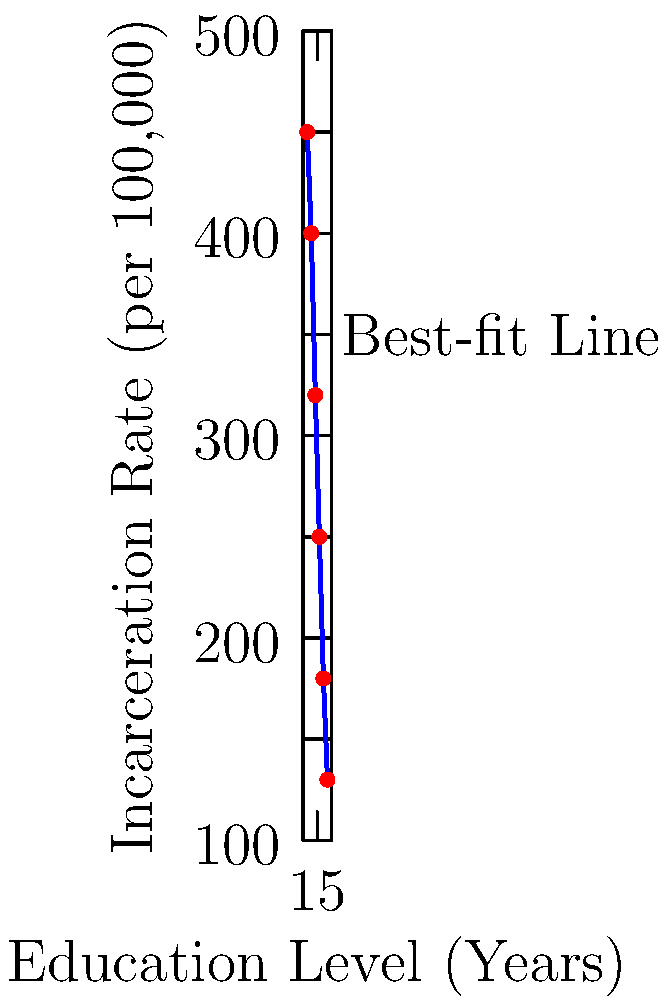Based on the scatter plot and best-fit line shown, which of the following statements best describes the relationship between education levels and incarceration rates? 

A) There is a strong positive correlation
B) There is a weak negative correlation
C) There is a strong negative correlation
D) There is no clear correlation To interpret the correlation between education levels and incarceration rates using the scatter plot and best-fit line, we need to analyze the following:

1. Direction of the relationship: The best-fit line slopes downward from left to right, indicating a negative relationship.

2. Strength of the relationship: The data points are closely clustered around the best-fit line, suggesting a strong relationship.

3. Pattern of the data points: The points follow a clear linear pattern, further supporting a strong correlation.

4. Quantitative assessment: While we don't have exact correlation coefficient, the visual representation strongly suggests a high negative correlation.

5. Interpretation: As education levels increase (x-axis), incarceration rates decrease (y-axis) in a consistent and substantial manner.

Given these observations, we can conclude that there is a strong negative correlation between education levels and incarceration rates. This means that higher levels of education are associated with lower incarceration rates.

Option C) "There is a strong negative correlation" best describes this relationship.
Answer: C) There is a strong negative correlation 